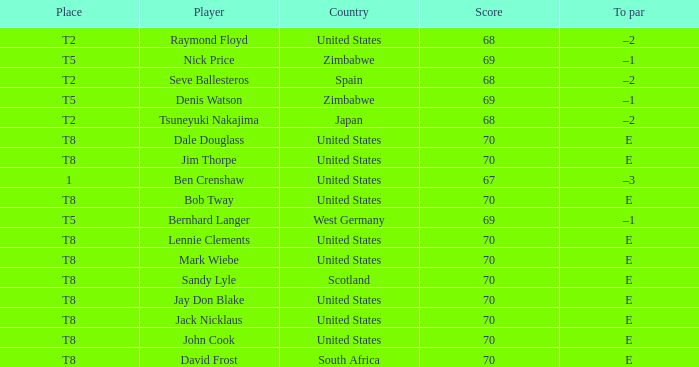What player has The United States as the country with 70 as the score? Jay Don Blake, Lennie Clements, John Cook, Dale Douglass, Jack Nicklaus, Jim Thorpe, Bob Tway, Mark Wiebe. 